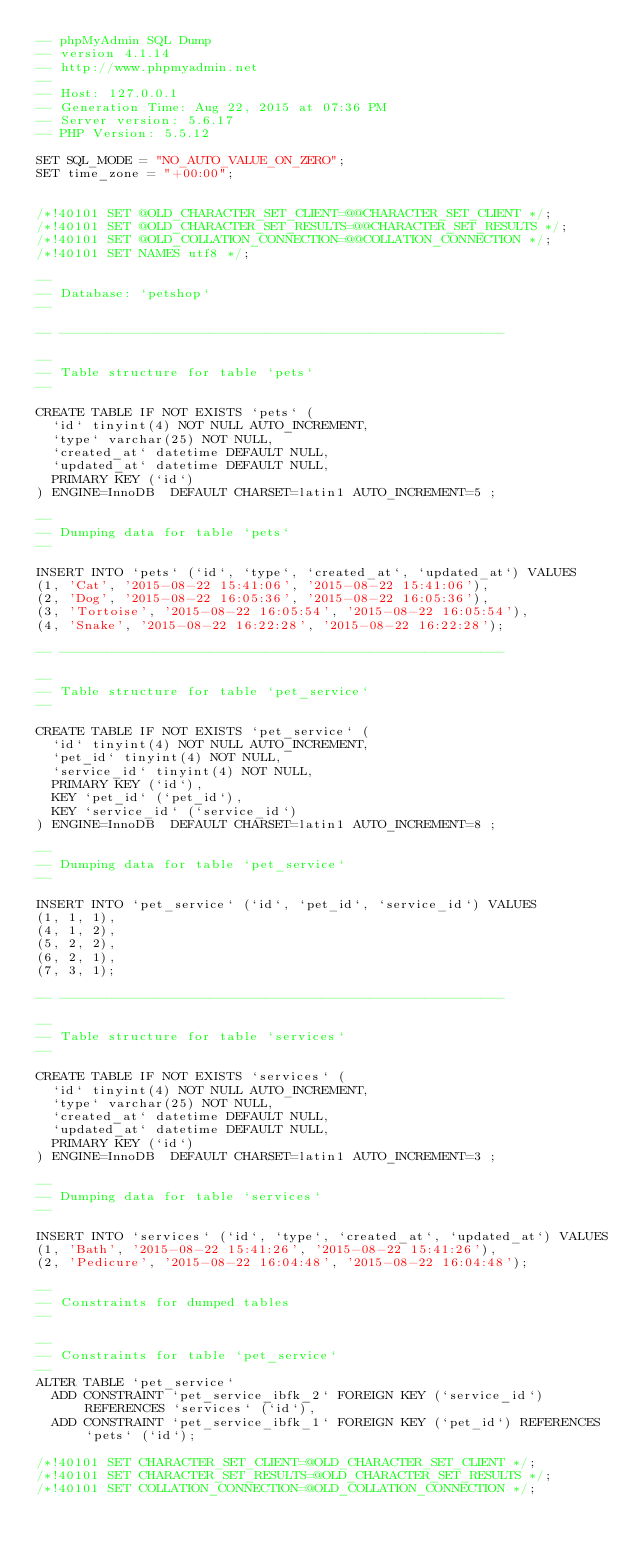<code> <loc_0><loc_0><loc_500><loc_500><_SQL_>-- phpMyAdmin SQL Dump
-- version 4.1.14
-- http://www.phpmyadmin.net
--
-- Host: 127.0.0.1
-- Generation Time: Aug 22, 2015 at 07:36 PM
-- Server version: 5.6.17
-- PHP Version: 5.5.12

SET SQL_MODE = "NO_AUTO_VALUE_ON_ZERO";
SET time_zone = "+00:00";


/*!40101 SET @OLD_CHARACTER_SET_CLIENT=@@CHARACTER_SET_CLIENT */;
/*!40101 SET @OLD_CHARACTER_SET_RESULTS=@@CHARACTER_SET_RESULTS */;
/*!40101 SET @OLD_COLLATION_CONNECTION=@@COLLATION_CONNECTION */;
/*!40101 SET NAMES utf8 */;

--
-- Database: `petshop`
--

-- --------------------------------------------------------

--
-- Table structure for table `pets`
--

CREATE TABLE IF NOT EXISTS `pets` (
  `id` tinyint(4) NOT NULL AUTO_INCREMENT,
  `type` varchar(25) NOT NULL,
  `created_at` datetime DEFAULT NULL,
  `updated_at` datetime DEFAULT NULL,
  PRIMARY KEY (`id`)
) ENGINE=InnoDB  DEFAULT CHARSET=latin1 AUTO_INCREMENT=5 ;

--
-- Dumping data for table `pets`
--

INSERT INTO `pets` (`id`, `type`, `created_at`, `updated_at`) VALUES
(1, 'Cat', '2015-08-22 15:41:06', '2015-08-22 15:41:06'),
(2, 'Dog', '2015-08-22 16:05:36', '2015-08-22 16:05:36'),
(3, 'Tortoise', '2015-08-22 16:05:54', '2015-08-22 16:05:54'),
(4, 'Snake', '2015-08-22 16:22:28', '2015-08-22 16:22:28');

-- --------------------------------------------------------

--
-- Table structure for table `pet_service`
--

CREATE TABLE IF NOT EXISTS `pet_service` (
  `id` tinyint(4) NOT NULL AUTO_INCREMENT,
  `pet_id` tinyint(4) NOT NULL,
  `service_id` tinyint(4) NOT NULL,
  PRIMARY KEY (`id`),
  KEY `pet_id` (`pet_id`),
  KEY `service_id` (`service_id`)
) ENGINE=InnoDB  DEFAULT CHARSET=latin1 AUTO_INCREMENT=8 ;

--
-- Dumping data for table `pet_service`
--

INSERT INTO `pet_service` (`id`, `pet_id`, `service_id`) VALUES
(1, 1, 1),
(4, 1, 2),
(5, 2, 2),
(6, 2, 1),
(7, 3, 1);

-- --------------------------------------------------------

--
-- Table structure for table `services`
--

CREATE TABLE IF NOT EXISTS `services` (
  `id` tinyint(4) NOT NULL AUTO_INCREMENT,
  `type` varchar(25) NOT NULL,
  `created_at` datetime DEFAULT NULL,
  `updated_at` datetime DEFAULT NULL,
  PRIMARY KEY (`id`)
) ENGINE=InnoDB  DEFAULT CHARSET=latin1 AUTO_INCREMENT=3 ;

--
-- Dumping data for table `services`
--

INSERT INTO `services` (`id`, `type`, `created_at`, `updated_at`) VALUES
(1, 'Bath', '2015-08-22 15:41:26', '2015-08-22 15:41:26'),
(2, 'Pedicure', '2015-08-22 16:04:48', '2015-08-22 16:04:48');

--
-- Constraints for dumped tables
--

--
-- Constraints for table `pet_service`
--
ALTER TABLE `pet_service`
  ADD CONSTRAINT `pet_service_ibfk_2` FOREIGN KEY (`service_id`) REFERENCES `services` (`id`),
  ADD CONSTRAINT `pet_service_ibfk_1` FOREIGN KEY (`pet_id`) REFERENCES `pets` (`id`);

/*!40101 SET CHARACTER_SET_CLIENT=@OLD_CHARACTER_SET_CLIENT */;
/*!40101 SET CHARACTER_SET_RESULTS=@OLD_CHARACTER_SET_RESULTS */;
/*!40101 SET COLLATION_CONNECTION=@OLD_COLLATION_CONNECTION */;
</code> 